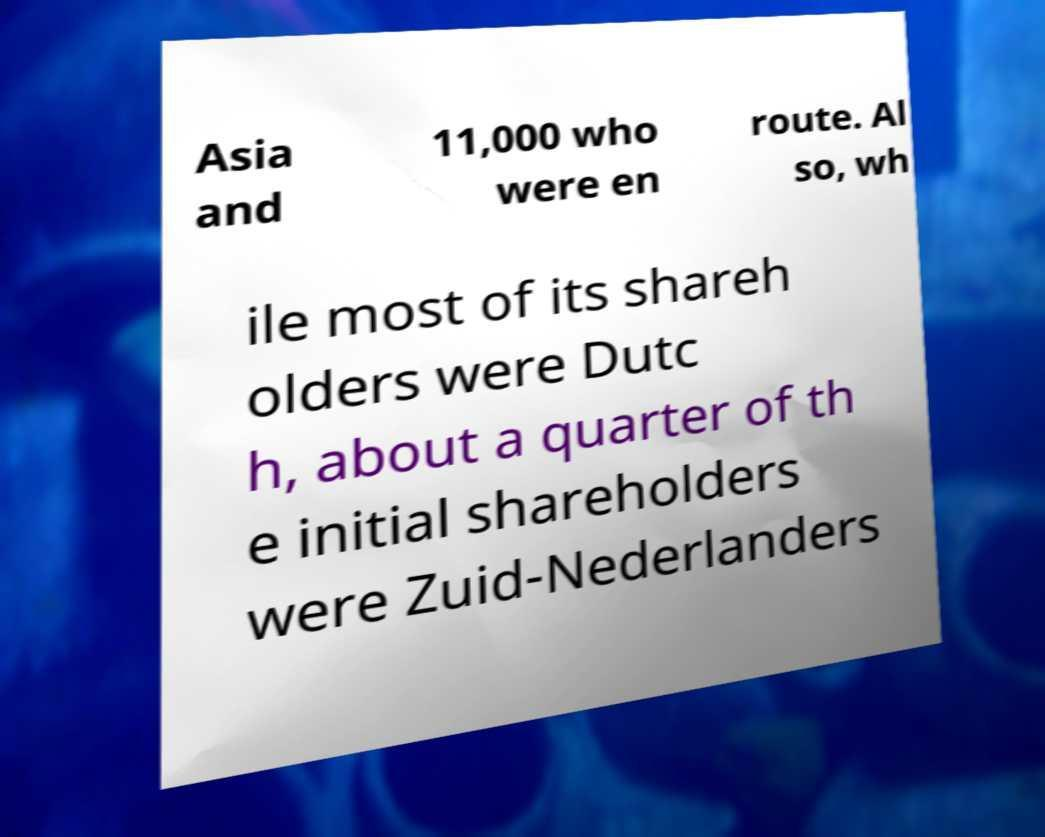Please identify and transcribe the text found in this image. Asia and 11,000 who were en route. Al so, wh ile most of its shareh olders were Dutc h, about a quarter of th e initial shareholders were Zuid-Nederlanders 